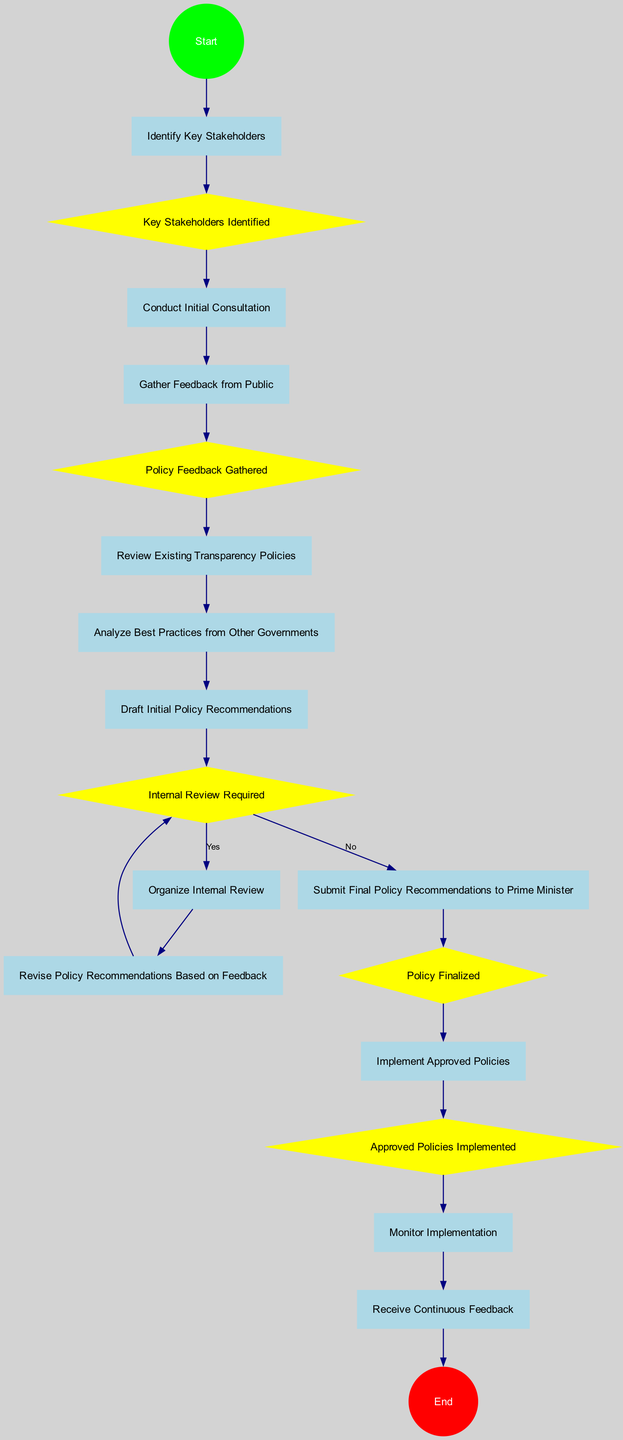What is the starting action in this diagram? The diagram begins with the action labeled "Start," indicating the initiation of the policy development process.
Answer: Start How many actions are present in the diagram? By counting the nodes classified as actions, I find there are eleven actions listed, indicating the steps involved in developing policy recommendations.
Answer: 11 What is the node that follows "Gather Feedback from Public"? The flow from "Gather Feedback from Public" leads to the decision node labeled "Policy Feedback Gathered," indicating the need to assess the feedback received before proceeding further.
Answer: Policy Feedback Gathered What happens after "Internal Review Required" if the answer is "Yes"? If the condition for "Internal Review Required" is true, the flow continues to "Organize Internal Review," which means an internal review process will be initiated for the policy recommendations.
Answer: Organize Internal Review Which action is taken before "Implement Approved Policies"? The action immediately preceding "Implement Approved Policies" is "Policy Finalized," meaning that the policies must first be finalized before any implementation can take place.
Answer: Policy Finalized What is the purpose of "Receive Continuous Feedback"? This action serves to continuously assess and adapt the policies post-implementation, ensuring they remain effective and transparent as they are executed in the government.
Answer: Continuous assessment What decision follows "Revise Policy Recommendations Based on Feedback"? After revising the recommendations based on feedback, the next step leads back to the decision node, "Internal Review Required," suggesting a cycle where feedback may prompt further internal reviews.
Answer: Internal Review Required What is the outcome if "Approved Policies Implemented" is accomplished? After achieving "Approved Policies Implemented," the diagram progresses to the action labeled "Monitor Implementation," which indicates that the implemented policies will be monitored for effectiveness.
Answer: Monitor Implementation How many decision nodes are there in the diagram? A careful count of all nodes identified as decisions reveals there are five decision nodes present in the diagram, each playing a crucial role in guiding the flow of the process.
Answer: 5 